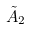Convert formula to latex. <formula><loc_0><loc_0><loc_500><loc_500>\tilde { A } _ { 2 }</formula> 